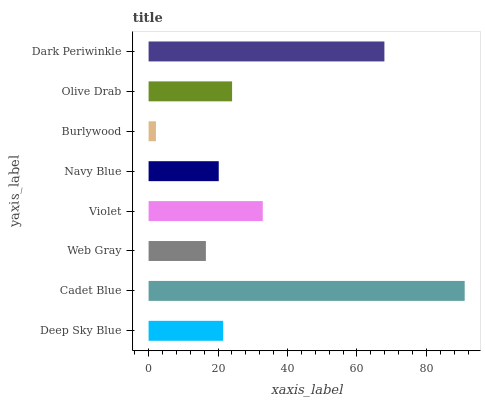Is Burlywood the minimum?
Answer yes or no. Yes. Is Cadet Blue the maximum?
Answer yes or no. Yes. Is Web Gray the minimum?
Answer yes or no. No. Is Web Gray the maximum?
Answer yes or no. No. Is Cadet Blue greater than Web Gray?
Answer yes or no. Yes. Is Web Gray less than Cadet Blue?
Answer yes or no. Yes. Is Web Gray greater than Cadet Blue?
Answer yes or no. No. Is Cadet Blue less than Web Gray?
Answer yes or no. No. Is Olive Drab the high median?
Answer yes or no. Yes. Is Deep Sky Blue the low median?
Answer yes or no. Yes. Is Navy Blue the high median?
Answer yes or no. No. Is Web Gray the low median?
Answer yes or no. No. 